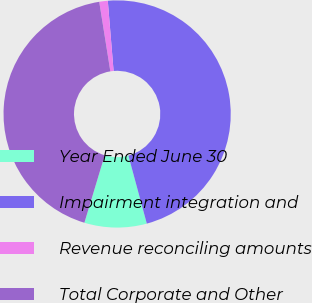Convert chart to OTSL. <chart><loc_0><loc_0><loc_500><loc_500><pie_chart><fcel>Year Ended June 30<fcel>Impairment integration and<fcel>Revenue reconciling amounts<fcel>Total Corporate and Other<nl><fcel>8.86%<fcel>47.1%<fcel>1.21%<fcel>42.82%<nl></chart> 